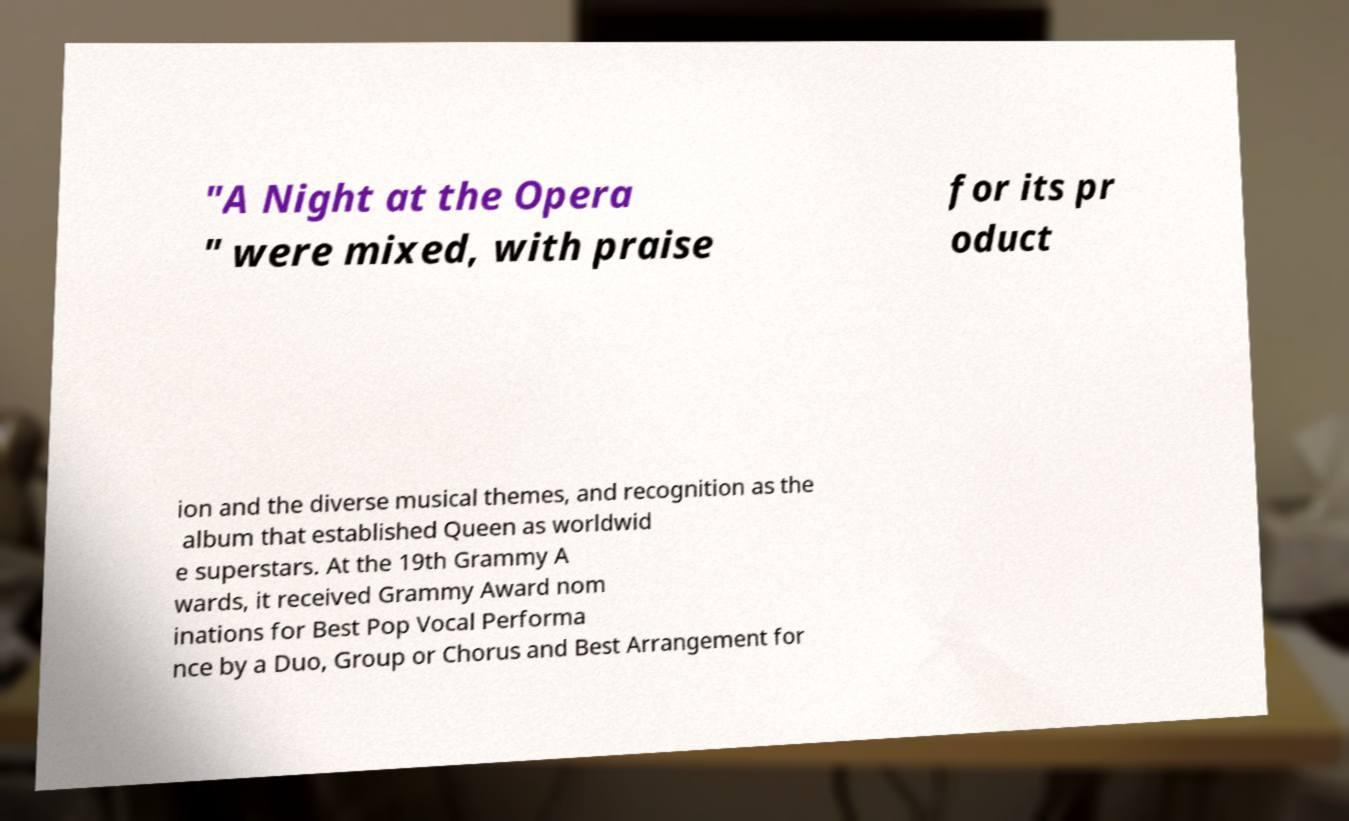Could you extract and type out the text from this image? "A Night at the Opera " were mixed, with praise for its pr oduct ion and the diverse musical themes, and recognition as the album that established Queen as worldwid e superstars. At the 19th Grammy A wards, it received Grammy Award nom inations for Best Pop Vocal Performa nce by a Duo, Group or Chorus and Best Arrangement for 